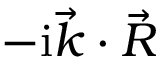Convert formula to latex. <formula><loc_0><loc_0><loc_500><loc_500>- i \vec { k } \cdot \vec { R }</formula> 